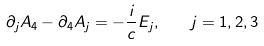<formula> <loc_0><loc_0><loc_500><loc_500>\partial _ { j } A _ { 4 } - \partial _ { 4 } A _ { j } = - \frac { i } { c } E _ { j } , \quad j = 1 , 2 , 3</formula> 